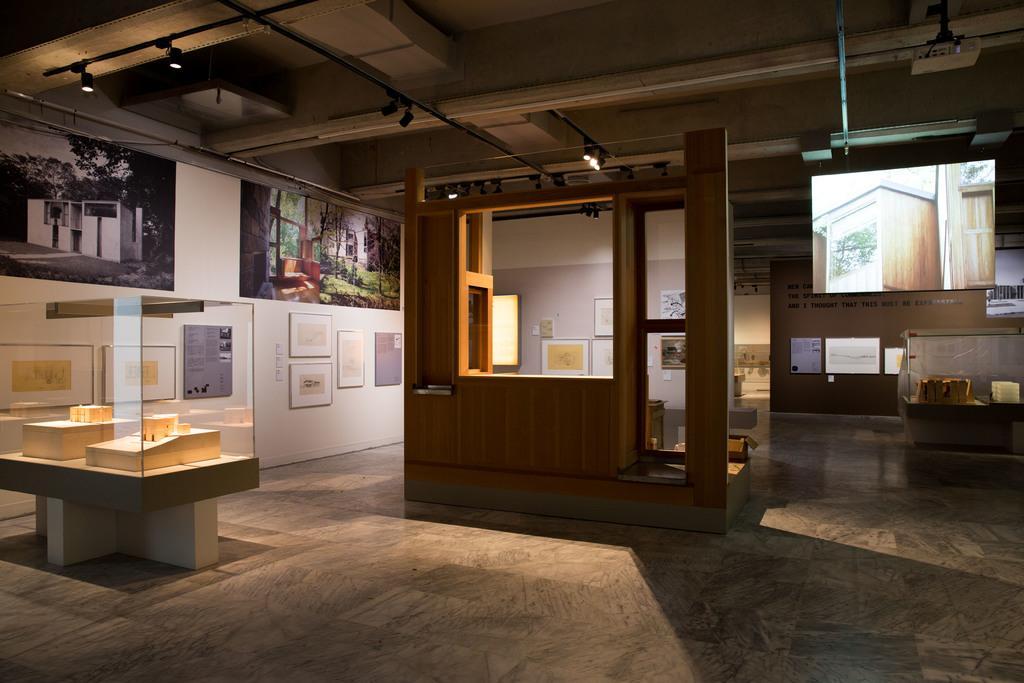How would you summarize this image in a sentence or two? In this picture we can see a glass object and a wooden item. Behind the glass object there is a wall with photos and other things. At the top there are lights. 